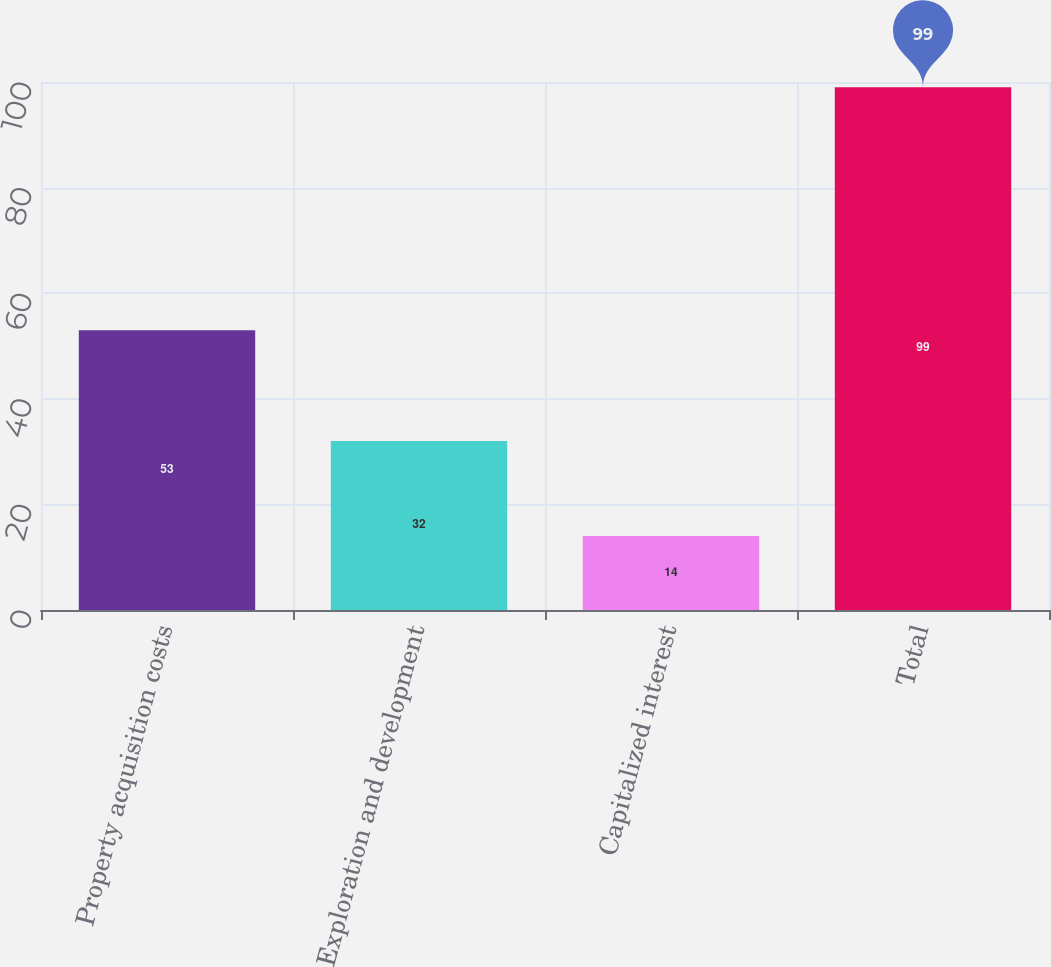Convert chart to OTSL. <chart><loc_0><loc_0><loc_500><loc_500><bar_chart><fcel>Property acquisition costs<fcel>Exploration and development<fcel>Capitalized interest<fcel>Total<nl><fcel>53<fcel>32<fcel>14<fcel>99<nl></chart> 